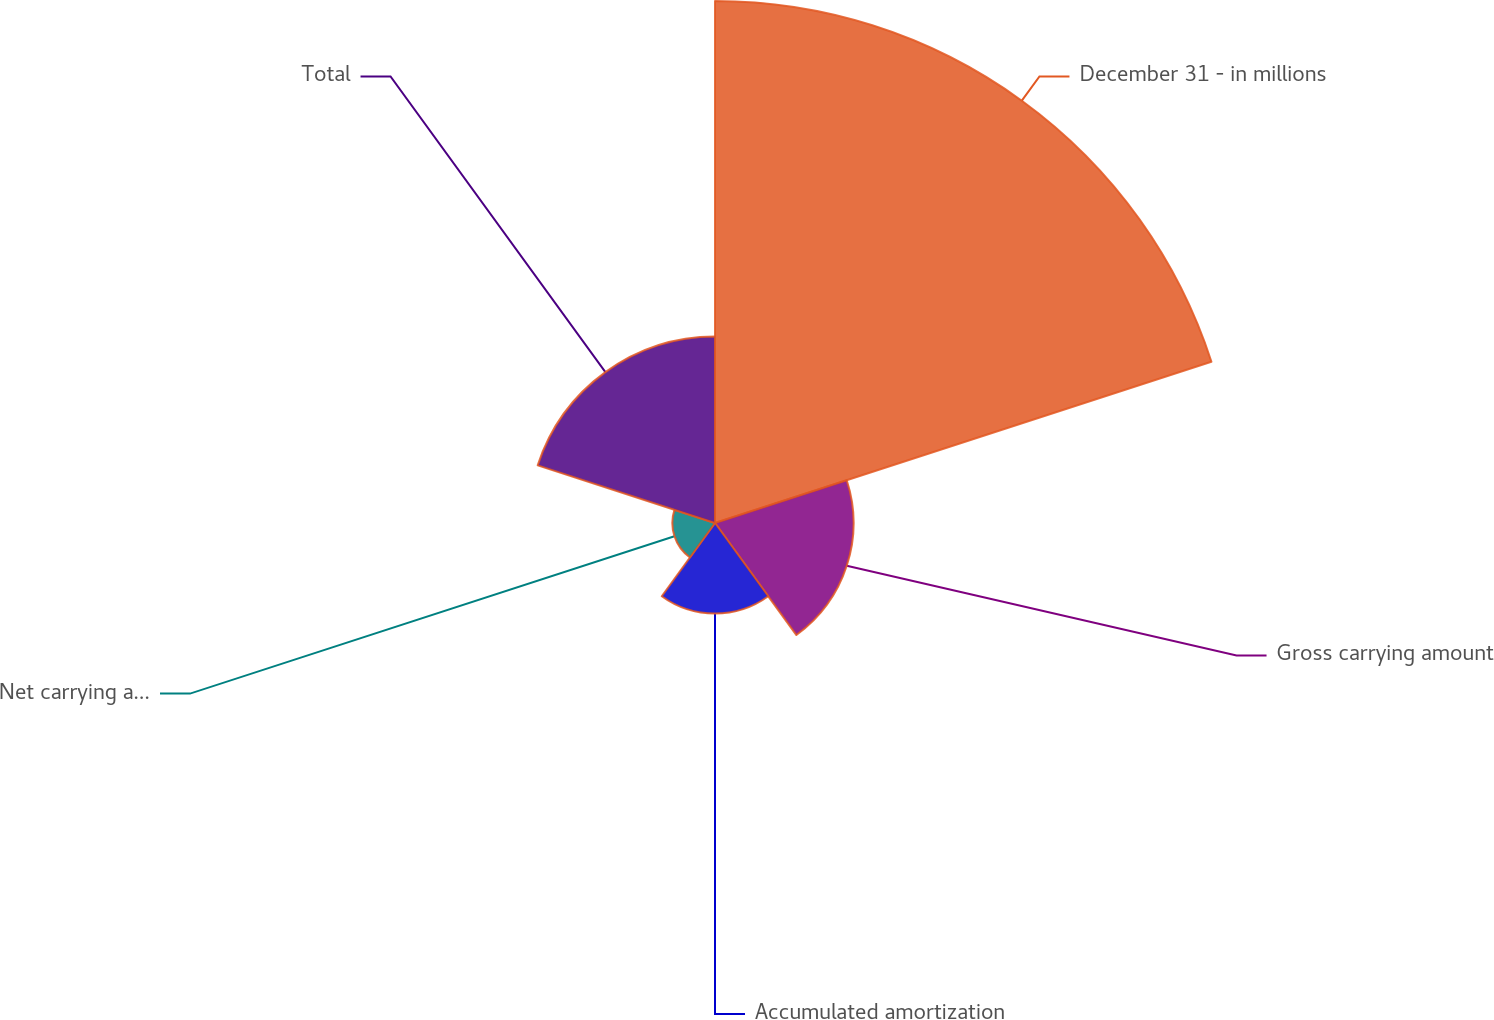<chart> <loc_0><loc_0><loc_500><loc_500><pie_chart><fcel>December 31 - in millions<fcel>Gross carrying amount<fcel>Accumulated amortization<fcel>Net carrying amount<fcel>Total<nl><fcel>53.25%<fcel>14.13%<fcel>9.24%<fcel>4.35%<fcel>19.02%<nl></chart> 